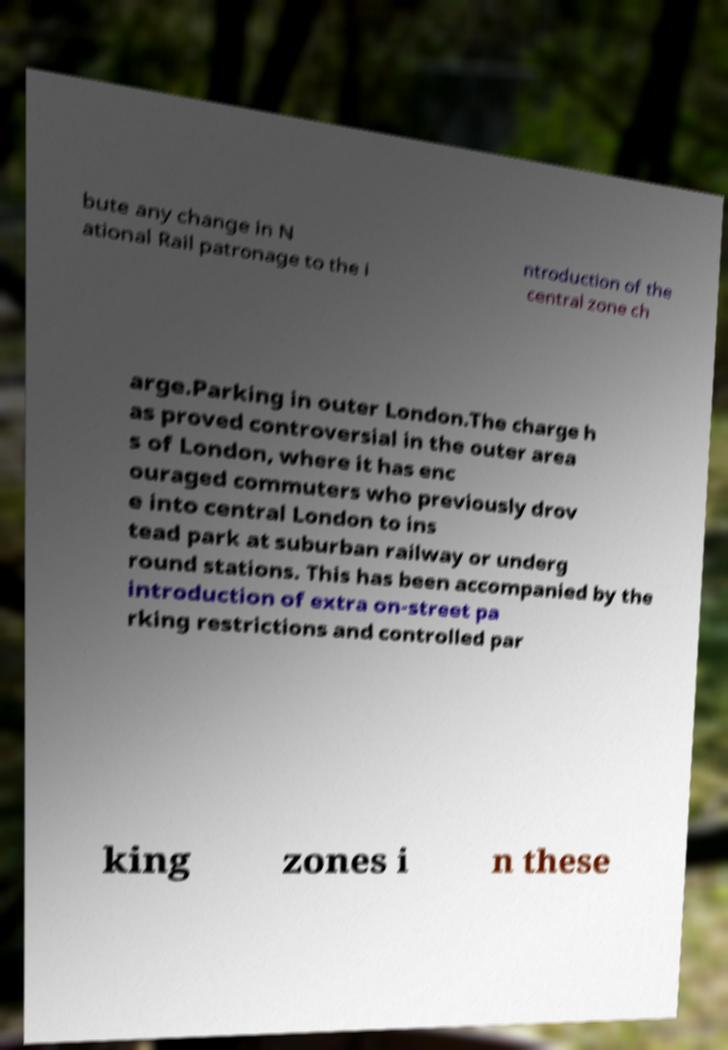For documentation purposes, I need the text within this image transcribed. Could you provide that? bute any change in N ational Rail patronage to the i ntroduction of the central zone ch arge.Parking in outer London.The charge h as proved controversial in the outer area s of London, where it has enc ouraged commuters who previously drov e into central London to ins tead park at suburban railway or underg round stations. This has been accompanied by the introduction of extra on-street pa rking restrictions and controlled par king zones i n these 